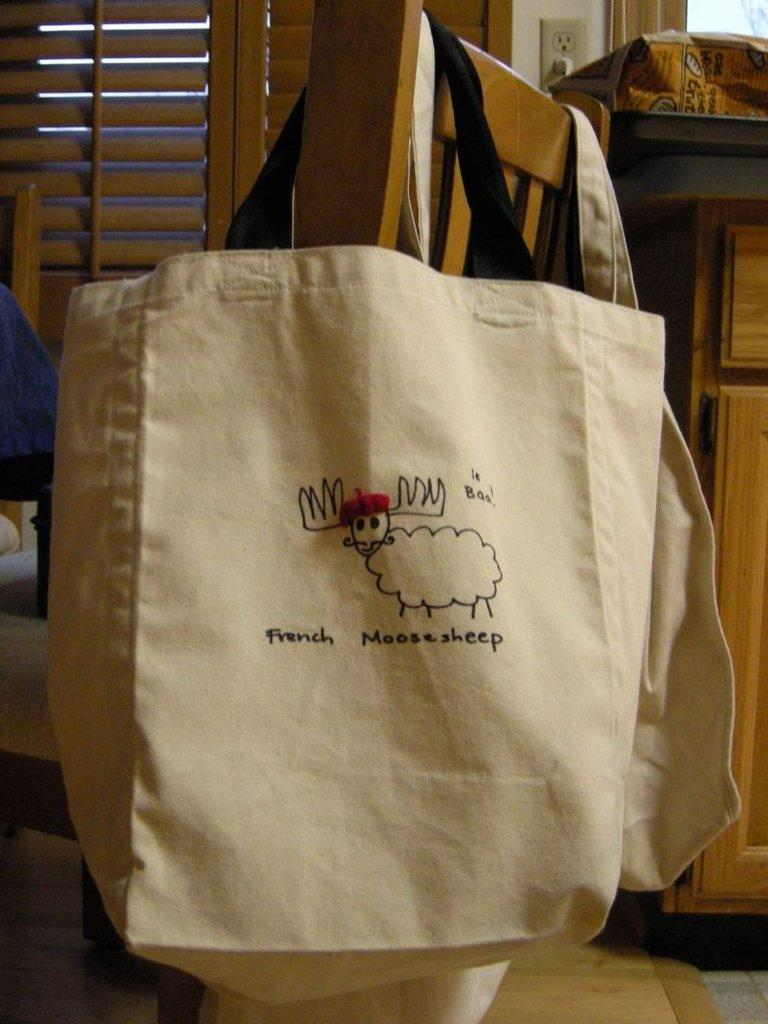What is the main object in the center of the image? There is a bag in the center of the image. What can be seen on the right side of the image? There is a desk on the right side of the image. Where is the window located in the image? The window is on the left top of the image. What is the surface that the bag and desk are placed on? The foreground of the image is a floor. Can you see any friends exchanging a crown in the image? There is no mention of friends, exchange, or a crown in the image. 